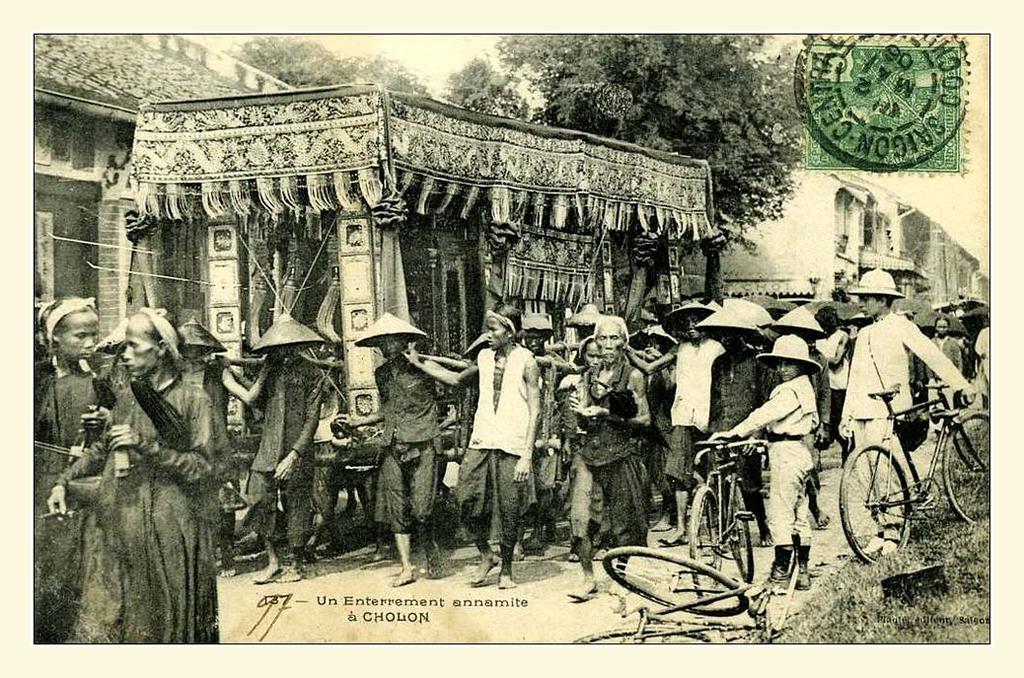Describe this image in one or two sentences. In this Image I see number of people who are on the path and most of them are wearing caps on their heads and I see cycles over here. In the background I see the buildings and the trees. 